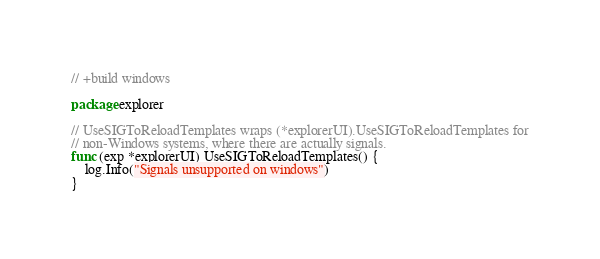Convert code to text. <code><loc_0><loc_0><loc_500><loc_500><_Go_>// +build windows

package explorer

// UseSIGToReloadTemplates wraps (*explorerUI).UseSIGToReloadTemplates for
// non-Windows systems, where there are actually signals.
func (exp *explorerUI) UseSIGToReloadTemplates() {
	log.Info("Signals unsupported on windows")
}
</code> 